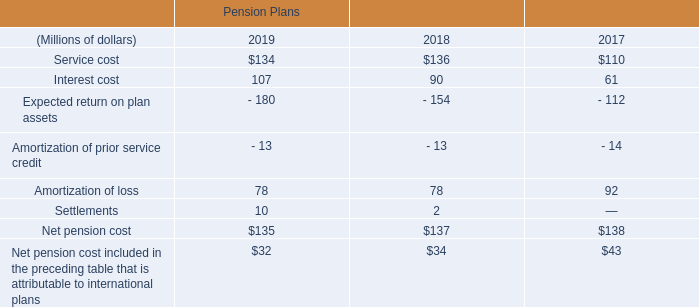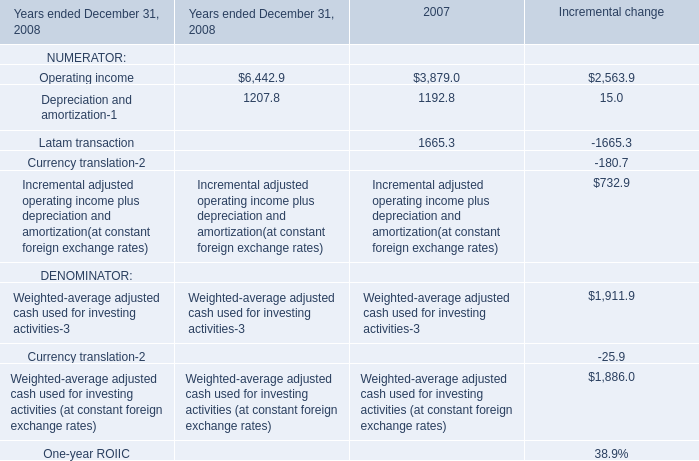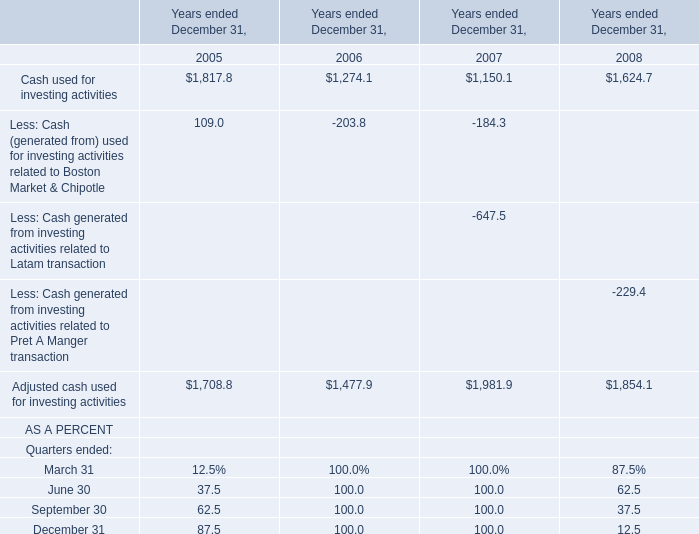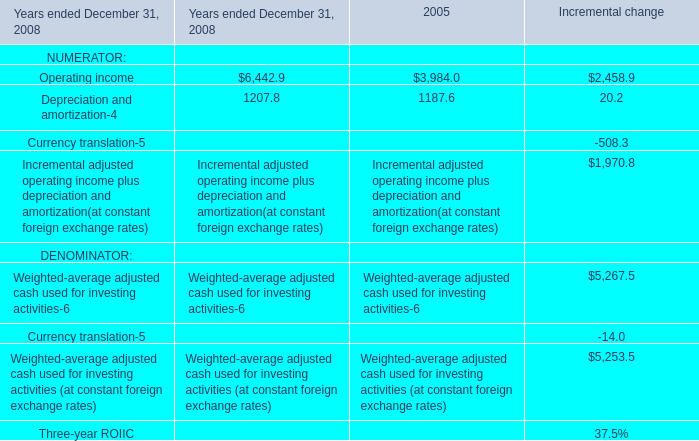In the year with larger amount of Operating income for NUMERATOR, what's the increasing rate of Depreciation and amortization for NUMERATOR? 
Computations: ((1207.8 - 1192.8) / 1192.8)
Answer: 0.01258. 